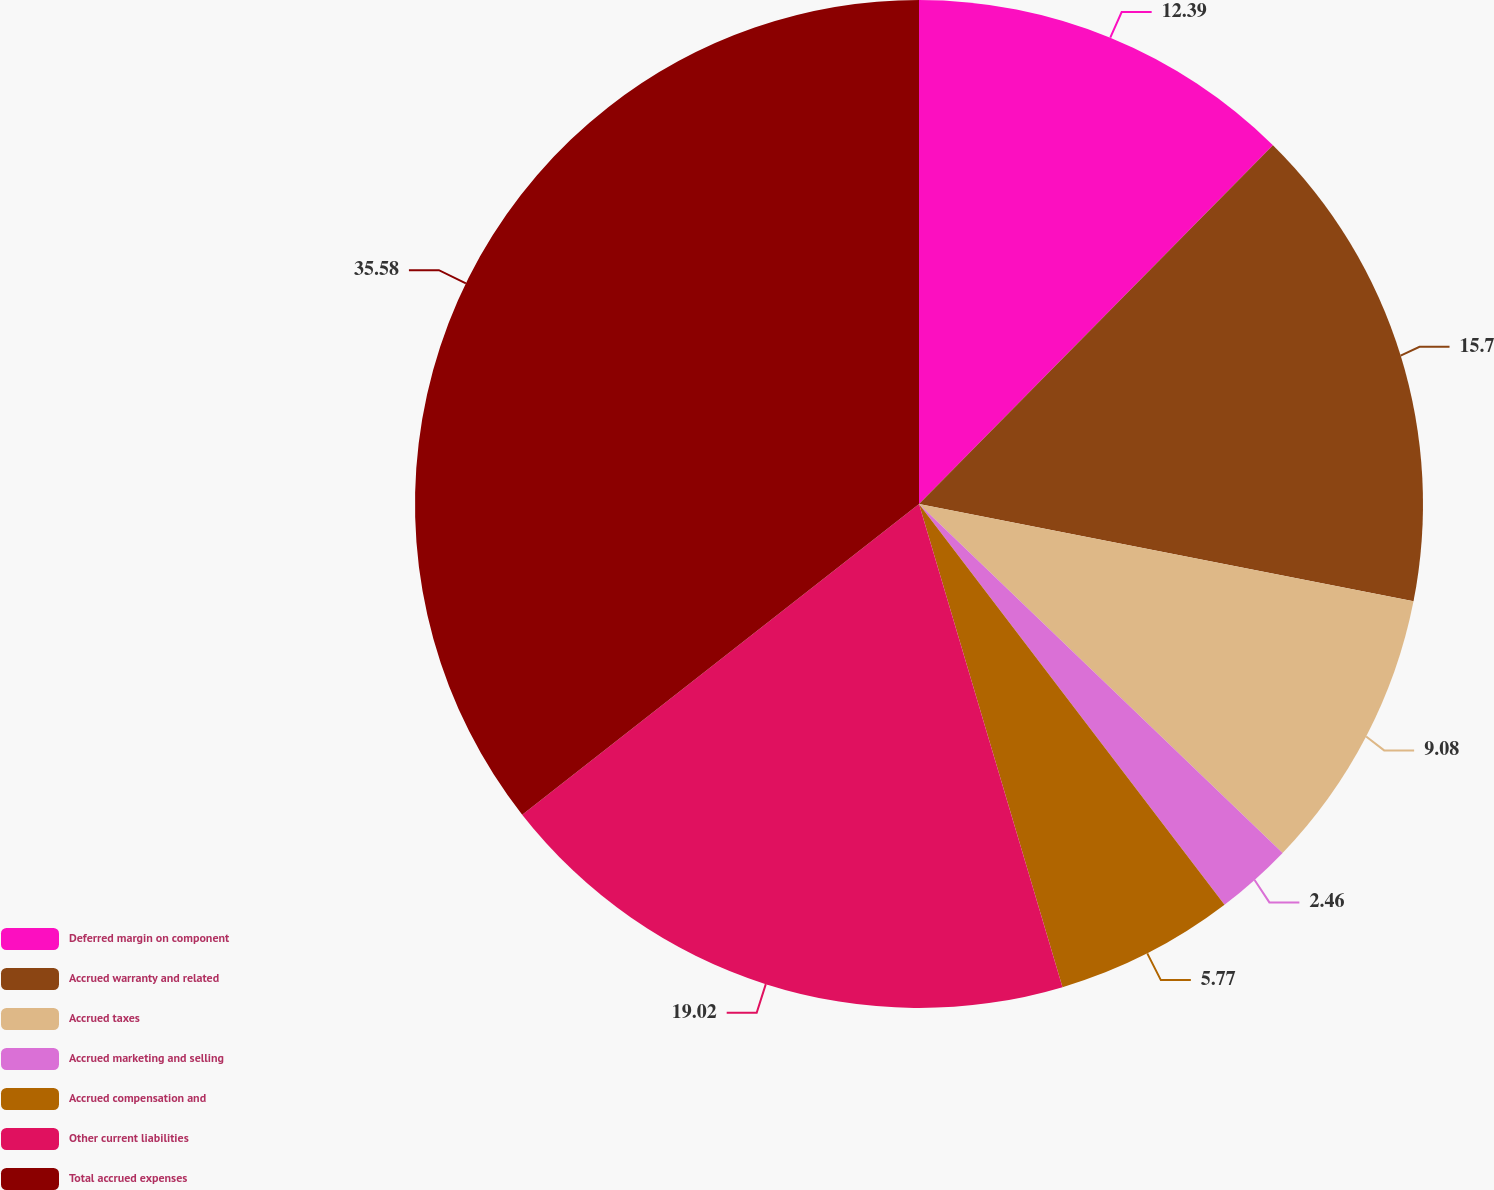Convert chart to OTSL. <chart><loc_0><loc_0><loc_500><loc_500><pie_chart><fcel>Deferred margin on component<fcel>Accrued warranty and related<fcel>Accrued taxes<fcel>Accrued marketing and selling<fcel>Accrued compensation and<fcel>Other current liabilities<fcel>Total accrued expenses<nl><fcel>12.39%<fcel>15.7%<fcel>9.08%<fcel>2.46%<fcel>5.77%<fcel>19.02%<fcel>35.57%<nl></chart> 